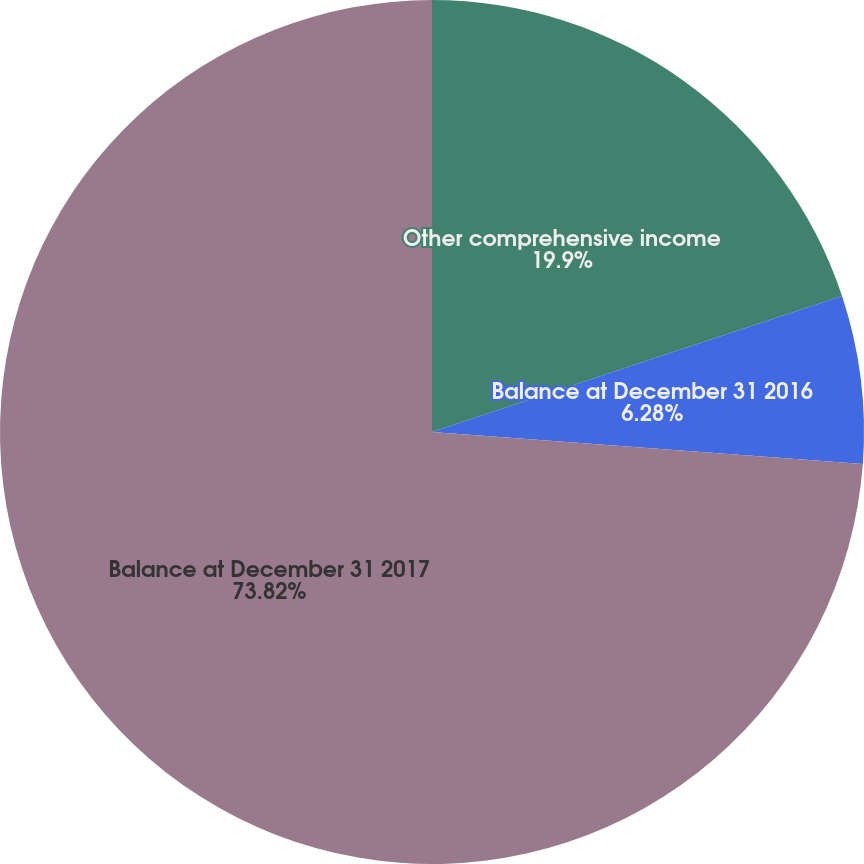Convert chart. <chart><loc_0><loc_0><loc_500><loc_500><pie_chart><fcel>Other comprehensive income<fcel>Balance at December 31 2016<fcel>Balance at December 31 2017<nl><fcel>19.9%<fcel>6.28%<fcel>73.82%<nl></chart> 